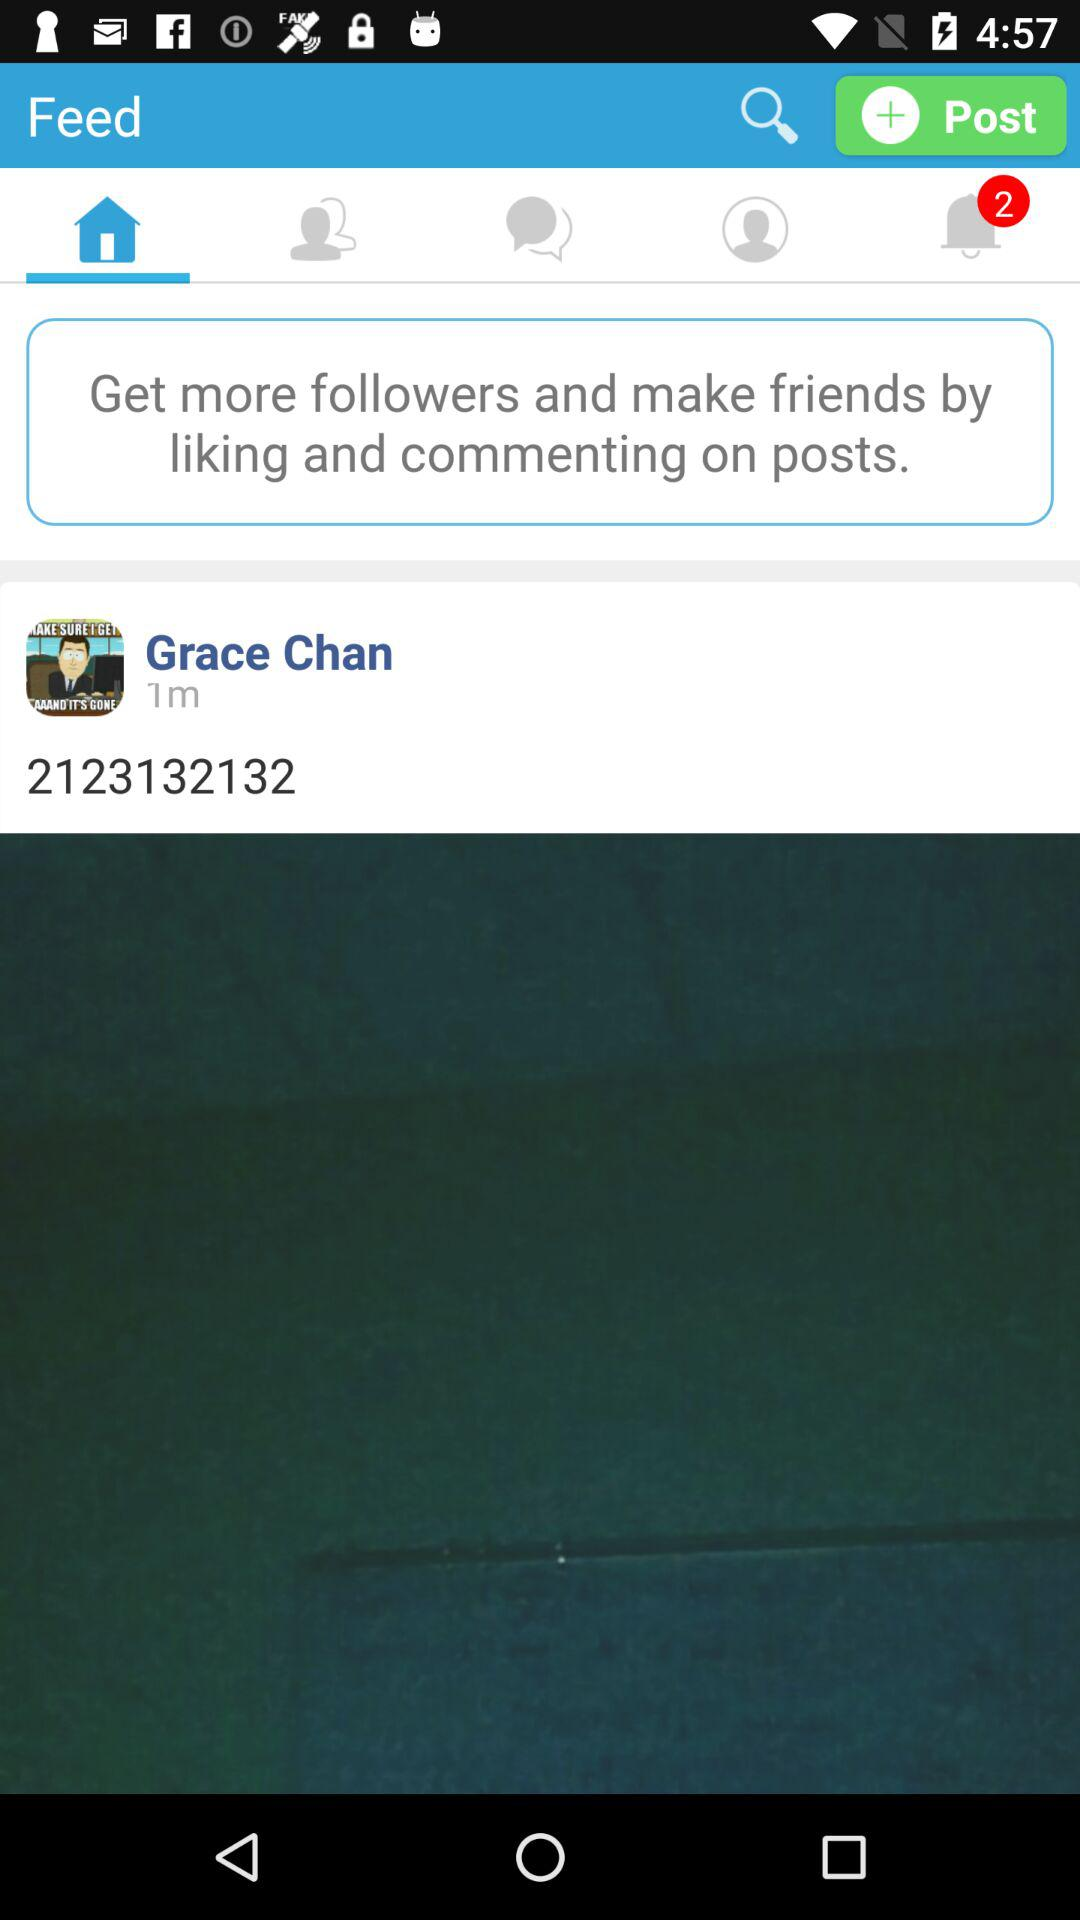What's the profile name? The profile name is Grace Chan. 